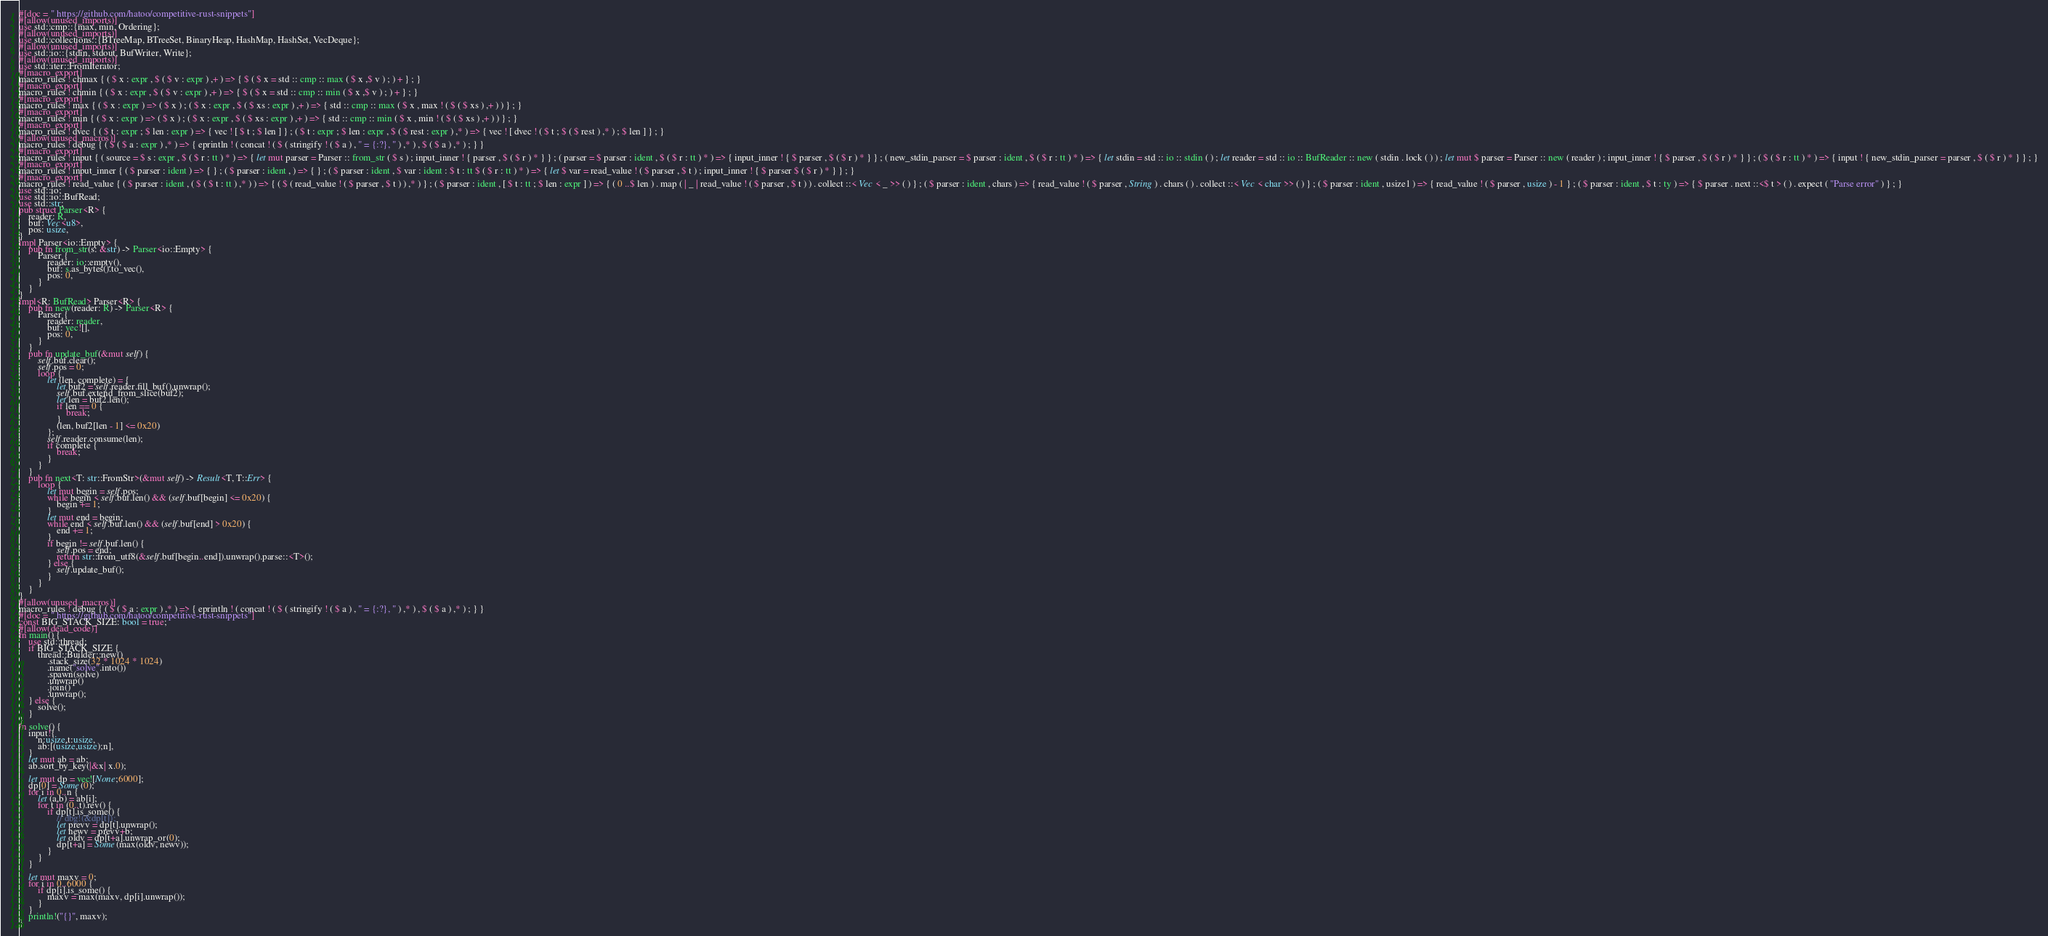Convert code to text. <code><loc_0><loc_0><loc_500><loc_500><_Rust_>#[doc = " https://github.com/hatoo/competitive-rust-snippets"]
#[allow(unused_imports)]
use std::cmp::{max, min, Ordering};
#[allow(unused_imports)]
use std::collections::{BTreeMap, BTreeSet, BinaryHeap, HashMap, HashSet, VecDeque};
#[allow(unused_imports)]
use std::io::{stdin, stdout, BufWriter, Write};
#[allow(unused_imports)]
use std::iter::FromIterator;
#[macro_export]
macro_rules ! chmax { ( $ x : expr , $ ( $ v : expr ) ,+ ) => { $ ( $ x = std :: cmp :: max ( $ x ,$ v ) ; ) + } ; }
#[macro_export]
macro_rules ! chmin { ( $ x : expr , $ ( $ v : expr ) ,+ ) => { $ ( $ x = std :: cmp :: min ( $ x ,$ v ) ; ) + } ; }
#[macro_export]
macro_rules ! max { ( $ x : expr ) => ( $ x ) ; ( $ x : expr , $ ( $ xs : expr ) ,+ ) => { std :: cmp :: max ( $ x , max ! ( $ ( $ xs ) ,+ ) ) } ; }
#[macro_export]
macro_rules ! min { ( $ x : expr ) => ( $ x ) ; ( $ x : expr , $ ( $ xs : expr ) ,+ ) => { std :: cmp :: min ( $ x , min ! ( $ ( $ xs ) ,+ ) ) } ; }
#[macro_export]
macro_rules ! dvec { ( $ t : expr ; $ len : expr ) => { vec ! [ $ t ; $ len ] } ; ( $ t : expr ; $ len : expr , $ ( $ rest : expr ) ,* ) => { vec ! [ dvec ! ( $ t ; $ ( $ rest ) ,* ) ; $ len ] } ; }
#[allow(unused_macros)]
macro_rules ! debug { ( $ ( $ a : expr ) ,* ) => { eprintln ! ( concat ! ( $ ( stringify ! ( $ a ) , " = {:?}, " ) ,* ) , $ ( $ a ) ,* ) ; } }
#[macro_export]
macro_rules ! input { ( source = $ s : expr , $ ( $ r : tt ) * ) => { let mut parser = Parser :: from_str ( $ s ) ; input_inner ! { parser , $ ( $ r ) * } } ; ( parser = $ parser : ident , $ ( $ r : tt ) * ) => { input_inner ! { $ parser , $ ( $ r ) * } } ; ( new_stdin_parser = $ parser : ident , $ ( $ r : tt ) * ) => { let stdin = std :: io :: stdin ( ) ; let reader = std :: io :: BufReader :: new ( stdin . lock ( ) ) ; let mut $ parser = Parser :: new ( reader ) ; input_inner ! { $ parser , $ ( $ r ) * } } ; ( $ ( $ r : tt ) * ) => { input ! { new_stdin_parser = parser , $ ( $ r ) * } } ; }
#[macro_export]
macro_rules ! input_inner { ( $ parser : ident ) => { } ; ( $ parser : ident , ) => { } ; ( $ parser : ident , $ var : ident : $ t : tt $ ( $ r : tt ) * ) => { let $ var = read_value ! ( $ parser , $ t ) ; input_inner ! { $ parser $ ( $ r ) * } } ; }
#[macro_export]
macro_rules ! read_value { ( $ parser : ident , ( $ ( $ t : tt ) ,* ) ) => { ( $ ( read_value ! ( $ parser , $ t ) ) ,* ) } ; ( $ parser : ident , [ $ t : tt ; $ len : expr ] ) => { ( 0 ..$ len ) . map ( | _ | read_value ! ( $ parser , $ t ) ) . collect ::< Vec < _ >> ( ) } ; ( $ parser : ident , chars ) => { read_value ! ( $ parser , String ) . chars ( ) . collect ::< Vec < char >> ( ) } ; ( $ parser : ident , usize1 ) => { read_value ! ( $ parser , usize ) - 1 } ; ( $ parser : ident , $ t : ty ) => { $ parser . next ::<$ t > ( ) . expect ( "Parse error" ) } ; }
use std::io;
use std::io::BufRead;
use std::str;
pub struct Parser<R> {
    reader: R,
    buf: Vec<u8>,
    pos: usize,
}
impl Parser<io::Empty> {
    pub fn from_str(s: &str) -> Parser<io::Empty> {
        Parser {
            reader: io::empty(),
            buf: s.as_bytes().to_vec(),
            pos: 0,
        }
    }
}
impl<R: BufRead> Parser<R> {
    pub fn new(reader: R) -> Parser<R> {
        Parser {
            reader: reader,
            buf: vec![],
            pos: 0,
        }
    }
    pub fn update_buf(&mut self) {
        self.buf.clear();
        self.pos = 0;
        loop {
            let (len, complete) = {
                let buf2 = self.reader.fill_buf().unwrap();
                self.buf.extend_from_slice(buf2);
                let len = buf2.len();
                if len == 0 {
                    break;
                }
                (len, buf2[len - 1] <= 0x20)
            };
            self.reader.consume(len);
            if complete {
                break;
            }
        }
    }
    pub fn next<T: str::FromStr>(&mut self) -> Result<T, T::Err> {
        loop {
            let mut begin = self.pos;
            while begin < self.buf.len() && (self.buf[begin] <= 0x20) {
                begin += 1;
            }
            let mut end = begin;
            while end < self.buf.len() && (self.buf[end] > 0x20) {
                end += 1;
            }
            if begin != self.buf.len() {
                self.pos = end;
                return str::from_utf8(&self.buf[begin..end]).unwrap().parse::<T>();
            } else {
                self.update_buf();
            }
        }
    }
}
#[allow(unused_macros)]
macro_rules ! debug { ( $ ( $ a : expr ) ,* ) => { eprintln ! ( concat ! ( $ ( stringify ! ( $ a ) , " = {:?}, " ) ,* ) , $ ( $ a ) ,* ) ; } }
#[doc = " https://github.com/hatoo/competitive-rust-snippets"]
const BIG_STACK_SIZE: bool = true;
#[allow(dead_code)]
fn main() {
    use std::thread;
    if BIG_STACK_SIZE {
        thread::Builder::new()
            .stack_size(32 * 1024 * 1024)
            .name("solve".into())
            .spawn(solve)
            .unwrap()
            .join()
            .unwrap();
    } else {
        solve();
    }
}
fn solve() {
    input!{
        n:usize,t:usize,
        ab:[(usize,usize);n],
    }
    let mut ab = ab;
    ab.sort_by_key(|&x| x.0);

    let mut dp = vec![None;6000];
    dp[0] = Some(0);
    for i in 0..n {
        let (a,b) = ab[i];
        for t in (0..t).rev() {
            if dp[t].is_some() {
                // dbg!(&dp[t]);
                let prevv = dp[t].unwrap();
                let newv = prevv+b;
                let oldv = dp[t+a].unwrap_or(0);
                dp[t+a] = Some(max(oldv, newv));
            }
        }
    }

    let mut maxv = 0;
    for i in 0..6000 {
        if dp[i].is_some() {
            maxv = max(maxv, dp[i].unwrap());
        }
    }
    println!("{}", maxv);
}</code> 